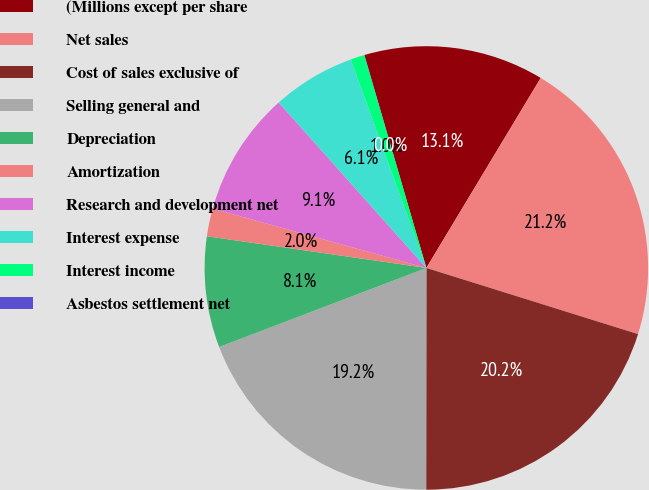Convert chart. <chart><loc_0><loc_0><loc_500><loc_500><pie_chart><fcel>(Millions except per share<fcel>Net sales<fcel>Cost of sales exclusive of<fcel>Selling general and<fcel>Depreciation<fcel>Amortization<fcel>Research and development net<fcel>Interest expense<fcel>Interest income<fcel>Asbestos settlement net<nl><fcel>13.13%<fcel>21.2%<fcel>20.19%<fcel>19.19%<fcel>8.08%<fcel>2.03%<fcel>9.09%<fcel>6.06%<fcel>1.02%<fcel>0.01%<nl></chart> 